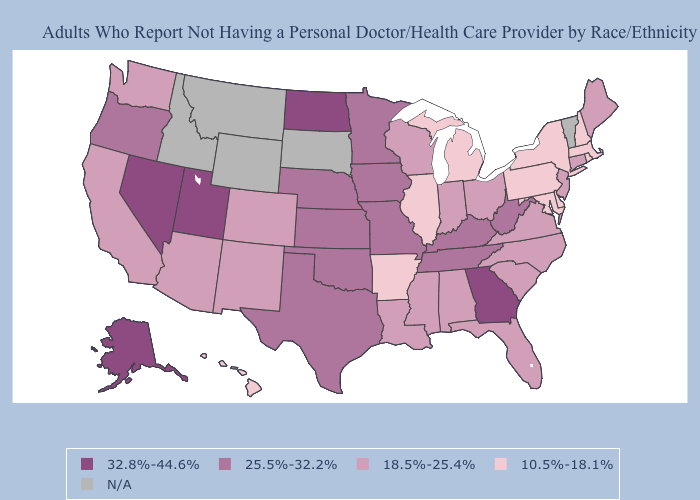Does West Virginia have the lowest value in the USA?
Be succinct. No. Among the states that border Kansas , which have the highest value?
Concise answer only. Missouri, Nebraska, Oklahoma. What is the value of Michigan?
Concise answer only. 10.5%-18.1%. What is the lowest value in the USA?
Quick response, please. 10.5%-18.1%. Which states have the lowest value in the Northeast?
Be succinct. Massachusetts, New Hampshire, New York, Pennsylvania, Rhode Island. Name the states that have a value in the range 18.5%-25.4%?
Write a very short answer. Alabama, Arizona, California, Colorado, Connecticut, Florida, Indiana, Louisiana, Maine, Mississippi, New Jersey, New Mexico, North Carolina, Ohio, South Carolina, Virginia, Washington, Wisconsin. Does Louisiana have the lowest value in the South?
Write a very short answer. No. What is the value of Nebraska?
Answer briefly. 25.5%-32.2%. Among the states that border Alabama , which have the highest value?
Keep it brief. Georgia. Name the states that have a value in the range 10.5%-18.1%?
Concise answer only. Arkansas, Delaware, Hawaii, Illinois, Maryland, Massachusetts, Michigan, New Hampshire, New York, Pennsylvania, Rhode Island. What is the value of Connecticut?
Keep it brief. 18.5%-25.4%. What is the highest value in states that border Wyoming?
Concise answer only. 32.8%-44.6%. Which states have the lowest value in the USA?
Keep it brief. Arkansas, Delaware, Hawaii, Illinois, Maryland, Massachusetts, Michigan, New Hampshire, New York, Pennsylvania, Rhode Island. Which states have the lowest value in the USA?
Answer briefly. Arkansas, Delaware, Hawaii, Illinois, Maryland, Massachusetts, Michigan, New Hampshire, New York, Pennsylvania, Rhode Island. 